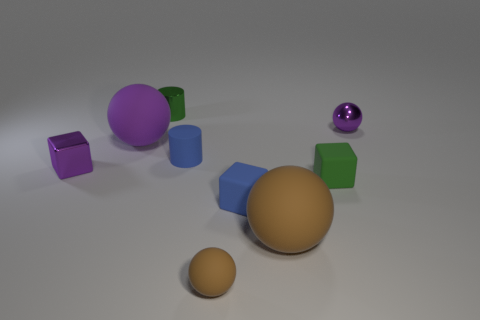How many purple balls must be subtracted to get 1 purple balls? 1 Subtract all small rubber cubes. How many cubes are left? 1 Subtract all blue cylinders. How many brown spheres are left? 2 Subtract all blue blocks. How many blocks are left? 2 Subtract 1 cylinders. How many cylinders are left? 1 Subtract all spheres. How many objects are left? 5 Add 6 tiny purple metal things. How many tiny purple metal things exist? 8 Subtract 0 cyan cylinders. How many objects are left? 9 Subtract all green spheres. Subtract all cyan cubes. How many spheres are left? 4 Subtract all big blue things. Subtract all big spheres. How many objects are left? 7 